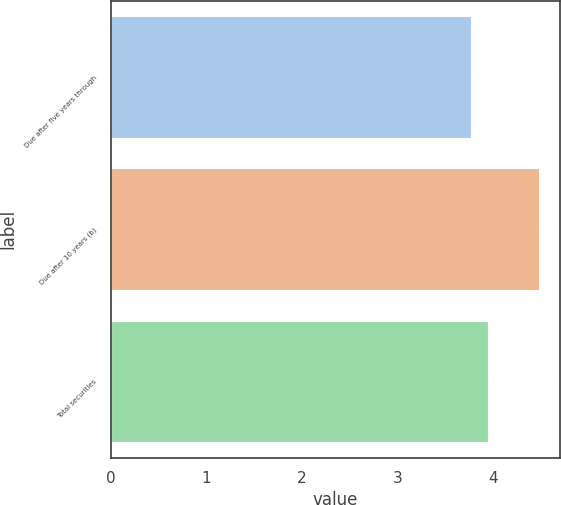<chart> <loc_0><loc_0><loc_500><loc_500><bar_chart><fcel>Due after five years through<fcel>Due after 10 years (b)<fcel>Total securities<nl><fcel>3.77<fcel>4.48<fcel>3.95<nl></chart> 